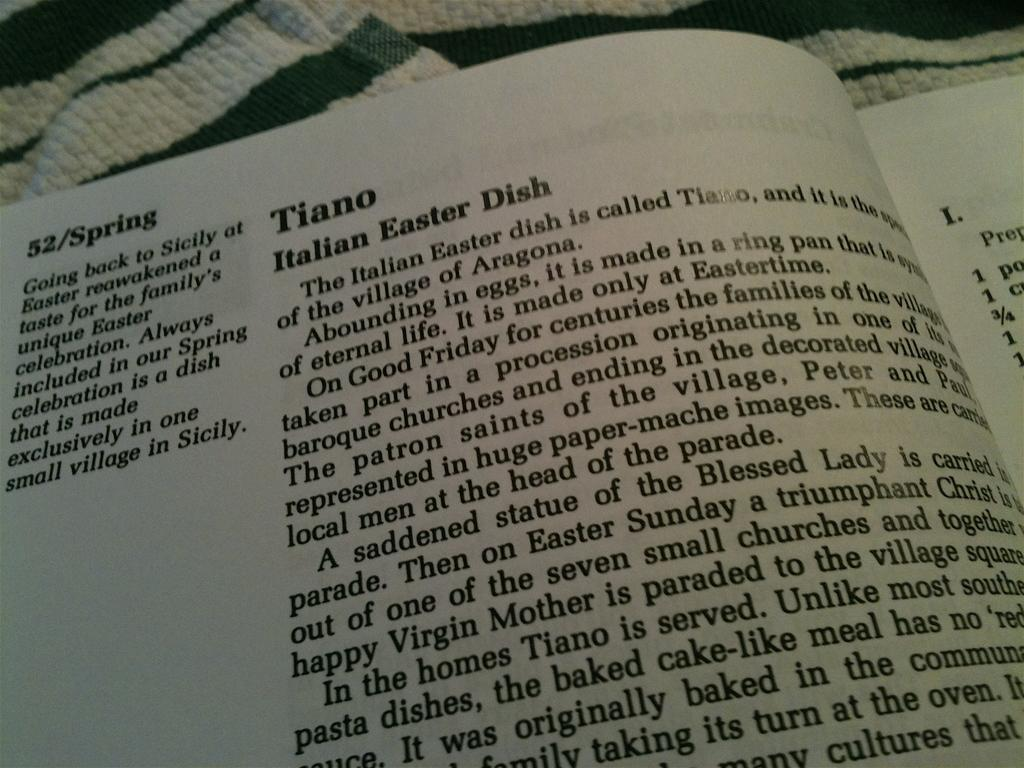<image>
Render a clear and concise summary of the photo. a book with the word dish on one of the pages 